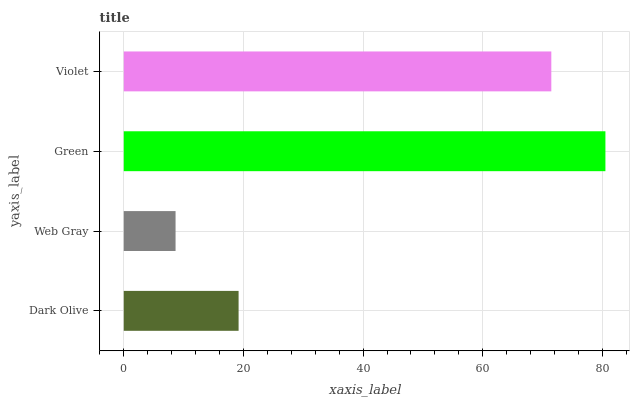Is Web Gray the minimum?
Answer yes or no. Yes. Is Green the maximum?
Answer yes or no. Yes. Is Green the minimum?
Answer yes or no. No. Is Web Gray the maximum?
Answer yes or no. No. Is Green greater than Web Gray?
Answer yes or no. Yes. Is Web Gray less than Green?
Answer yes or no. Yes. Is Web Gray greater than Green?
Answer yes or no. No. Is Green less than Web Gray?
Answer yes or no. No. Is Violet the high median?
Answer yes or no. Yes. Is Dark Olive the low median?
Answer yes or no. Yes. Is Dark Olive the high median?
Answer yes or no. No. Is Green the low median?
Answer yes or no. No. 